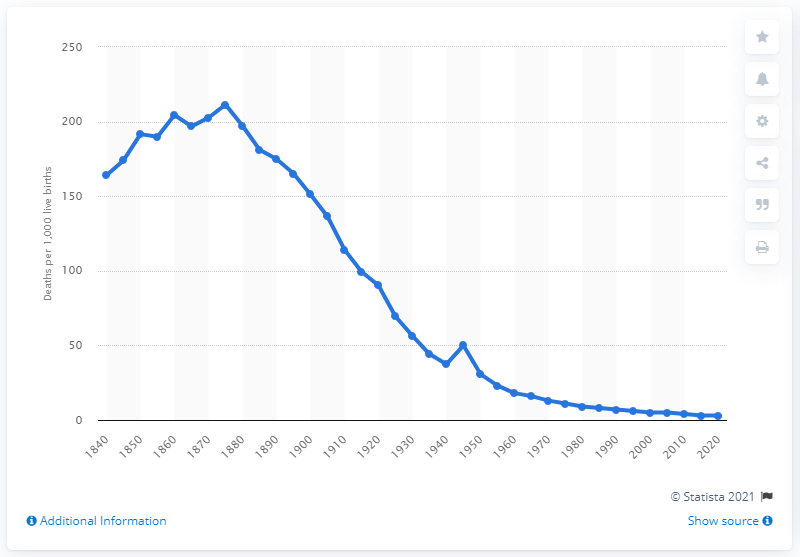Highlight a few significant elements in this photo. In 1840, it is estimated that a significant percentage of babies born did not survive past their first birthday. 